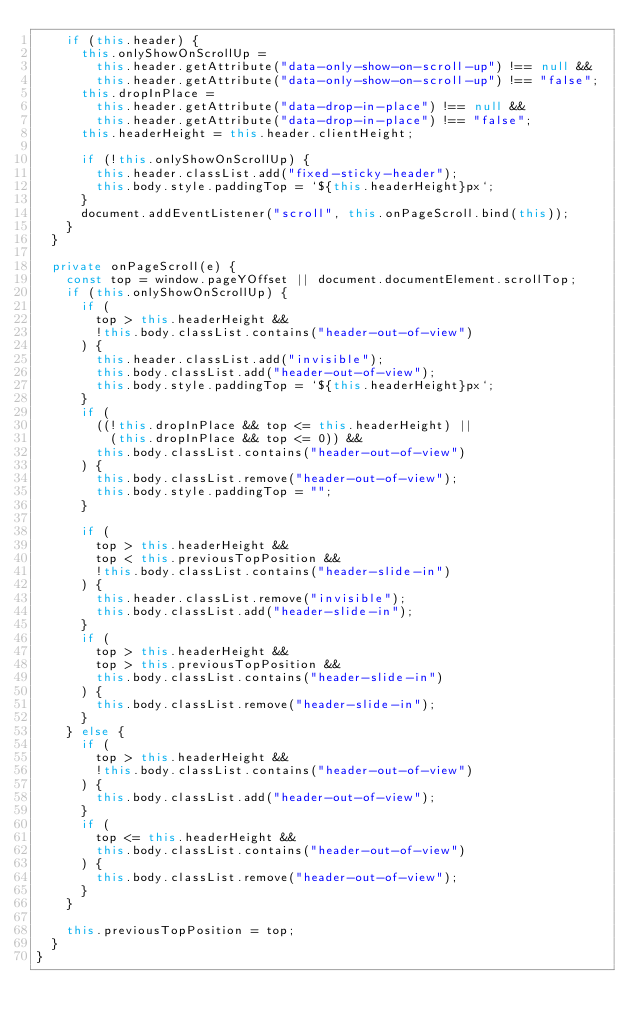Convert code to text. <code><loc_0><loc_0><loc_500><loc_500><_TypeScript_>    if (this.header) {
      this.onlyShowOnScrollUp =
        this.header.getAttribute("data-only-show-on-scroll-up") !== null &&
        this.header.getAttribute("data-only-show-on-scroll-up") !== "false";
      this.dropInPlace =
        this.header.getAttribute("data-drop-in-place") !== null &&
        this.header.getAttribute("data-drop-in-place") !== "false";
      this.headerHeight = this.header.clientHeight;

      if (!this.onlyShowOnScrollUp) {
        this.header.classList.add("fixed-sticky-header");
        this.body.style.paddingTop = `${this.headerHeight}px`;
      }
      document.addEventListener("scroll", this.onPageScroll.bind(this));
    }
  }

  private onPageScroll(e) {
    const top = window.pageYOffset || document.documentElement.scrollTop;
    if (this.onlyShowOnScrollUp) {
      if (
        top > this.headerHeight &&
        !this.body.classList.contains("header-out-of-view")
      ) {
        this.header.classList.add("invisible");
        this.body.classList.add("header-out-of-view");
        this.body.style.paddingTop = `${this.headerHeight}px`;
      }
      if (
        ((!this.dropInPlace && top <= this.headerHeight) ||
          (this.dropInPlace && top <= 0)) &&
        this.body.classList.contains("header-out-of-view")
      ) {
        this.body.classList.remove("header-out-of-view");
        this.body.style.paddingTop = "";
      }

      if (
        top > this.headerHeight &&
        top < this.previousTopPosition &&
        !this.body.classList.contains("header-slide-in")
      ) {
        this.header.classList.remove("invisible");
        this.body.classList.add("header-slide-in");
      }
      if (
        top > this.headerHeight &&
        top > this.previousTopPosition &&
        this.body.classList.contains("header-slide-in")
      ) {
        this.body.classList.remove("header-slide-in");
      }
    } else {
      if (
        top > this.headerHeight &&
        !this.body.classList.contains("header-out-of-view")
      ) {
        this.body.classList.add("header-out-of-view");
      }
      if (
        top <= this.headerHeight &&
        this.body.classList.contains("header-out-of-view")
      ) {
        this.body.classList.remove("header-out-of-view");
      }
    }

    this.previousTopPosition = top;
  }
}
</code> 